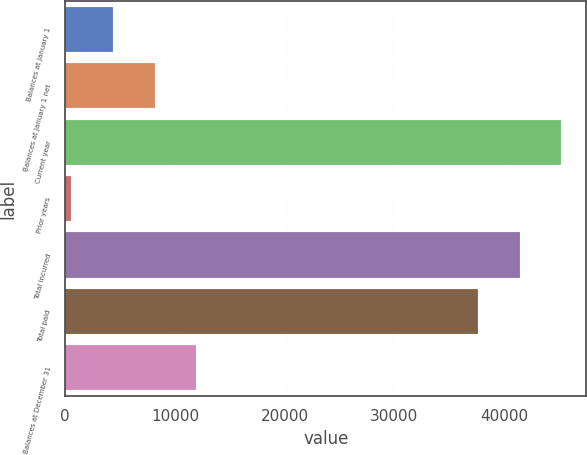Convert chart. <chart><loc_0><loc_0><loc_500><loc_500><bar_chart><fcel>Balances at January 1<fcel>Balances at January 1 net<fcel>Current year<fcel>Prior years<fcel>Total incurred<fcel>Total paid<fcel>Balances at December 31<nl><fcel>4330.3<fcel>8142.6<fcel>45243.6<fcel>518<fcel>41431.3<fcel>37619<fcel>11954.9<nl></chart> 